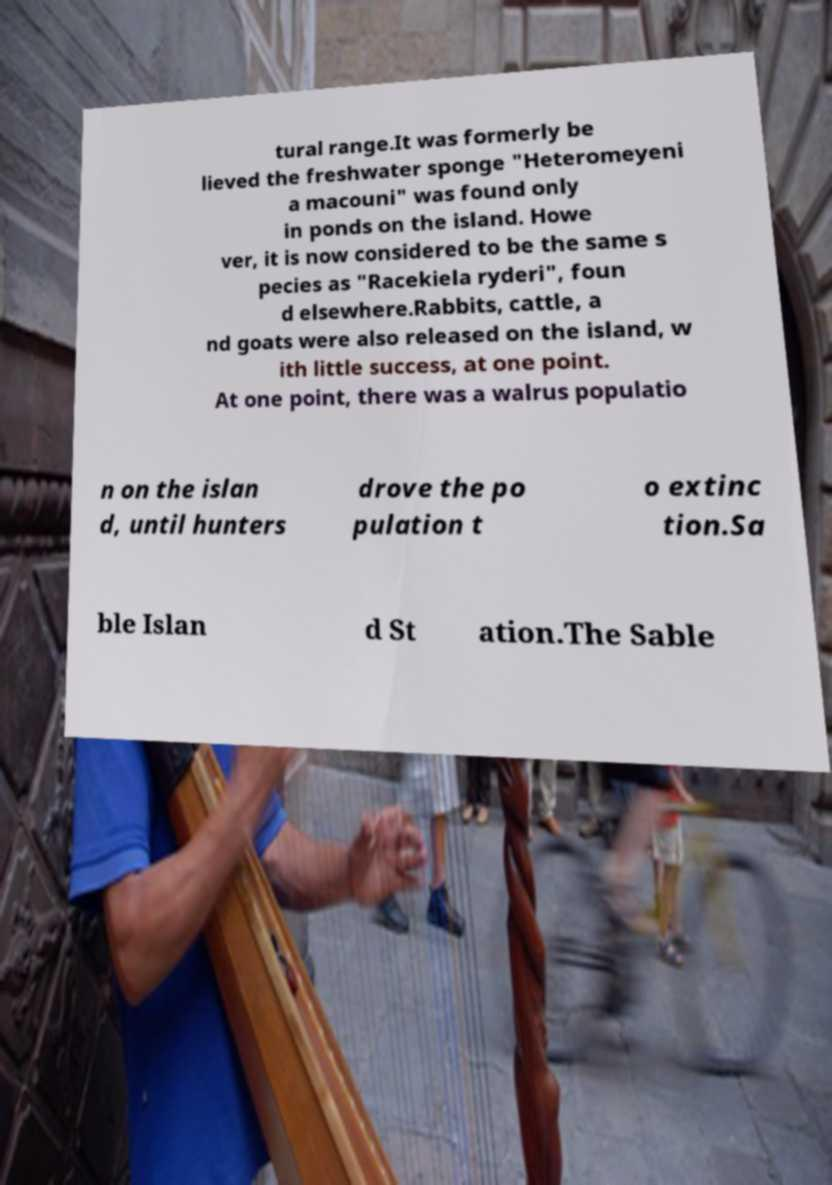What messages or text are displayed in this image? I need them in a readable, typed format. tural range.It was formerly be lieved the freshwater sponge "Heteromeyeni a macouni" was found only in ponds on the island. Howe ver, it is now considered to be the same s pecies as "Racekiela ryderi", foun d elsewhere.Rabbits, cattle, a nd goats were also released on the island, w ith little success, at one point. At one point, there was a walrus populatio n on the islan d, until hunters drove the po pulation t o extinc tion.Sa ble Islan d St ation.The Sable 